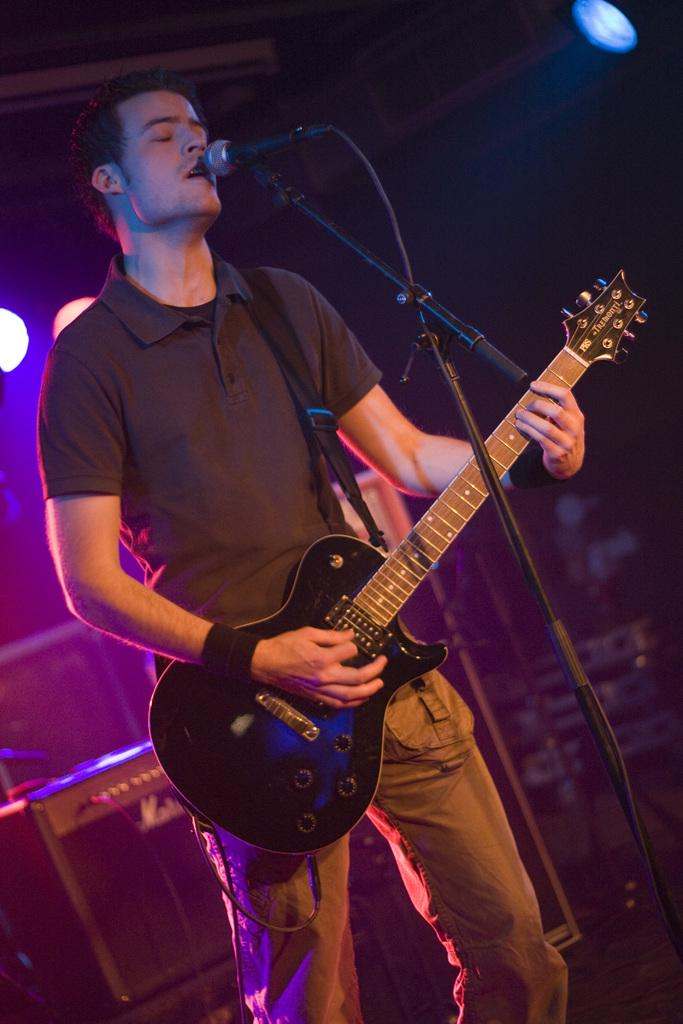What is the man in the image doing? The man is playing a guitar in the image. What object is present in the image that is typically used for amplifying sound? There is a microphone, referred to as "mike," in the image. What can be seen in the image that provides illumination? There is a light in the image. How many bulbs are visible in the image? There is no bulb present in the image. What type of business is being conducted in the image? The image does not depict any business activity; it shows a man playing a guitar with a microphone and a light nearby. 